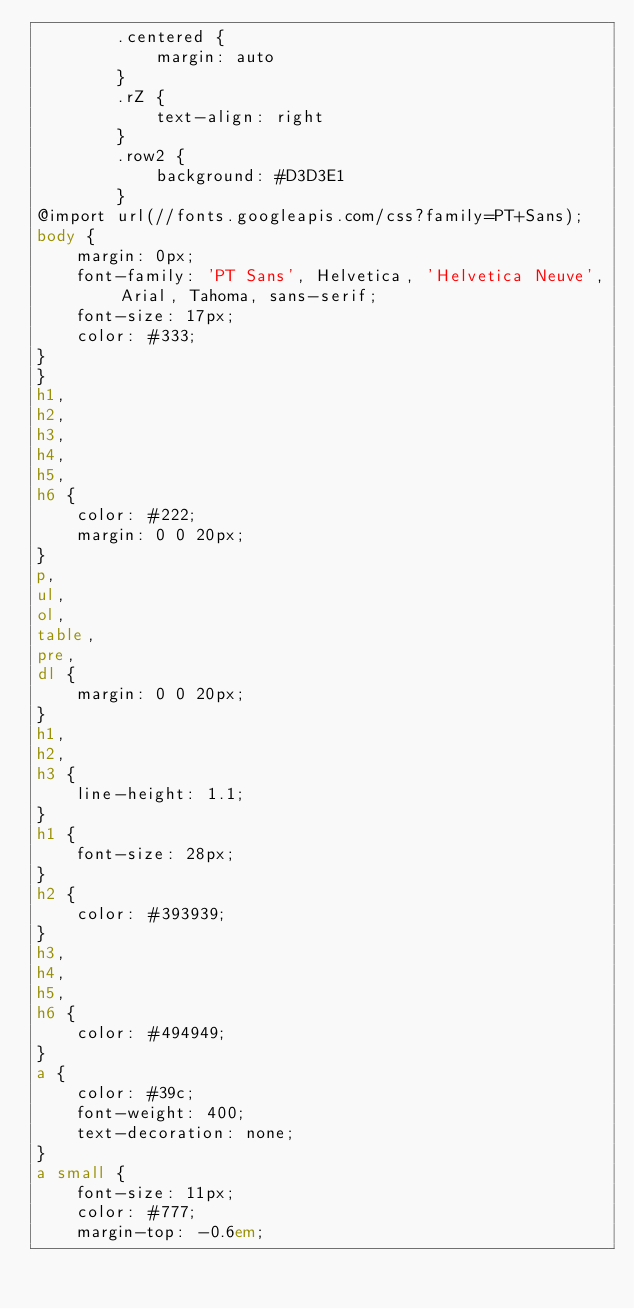Convert code to text. <code><loc_0><loc_0><loc_500><loc_500><_HTML_>        .centered {
            margin: auto
        }
        .rZ {
            text-align: right
        }
        .row2 {
            background: #D3D3E1
        }
@import url(//fonts.googleapis.com/css?family=PT+Sans);
body {
    margin: 0px;
    font-family: 'PT Sans', Helvetica, 'Helvetica Neuve', Arial, Tahoma, sans-serif;
    font-size: 17px;
    color: #333;
}
}
h1,
h2,
h3,
h4,
h5,
h6 {
    color: #222;
    margin: 0 0 20px;
}
p,
ul,
ol,
table,
pre,
dl {
    margin: 0 0 20px;
}
h1,
h2,
h3 {
    line-height: 1.1;
}
h1 {
    font-size: 28px;
}
h2 {
    color: #393939;
}
h3,
h4,
h5,
h6 {
    color: #494949;
}
a {
    color: #39c;
    font-weight: 400;
    text-decoration: none;
}
a small {
    font-size: 11px;
    color: #777;
    margin-top: -0.6em;</code> 